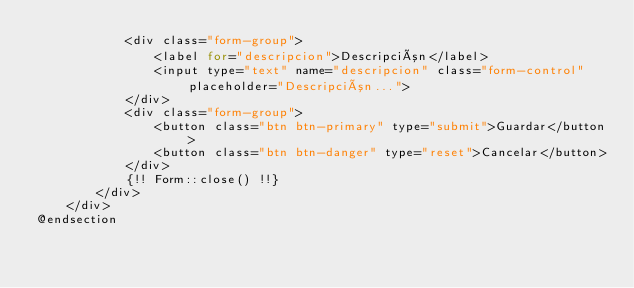Convert code to text. <code><loc_0><loc_0><loc_500><loc_500><_PHP_>            <div class="form-group">
                <label for="descripcion">Descripción</label>
                <input type="text" name="descripcion" class="form-control" placeholder="Descripción...">
            </div>
            <div class="form-group">
                <button class="btn btn-primary" type="submit">Guardar</button>
                <button class="btn btn-danger" type="reset">Cancelar</button>
            </div>
            {!! Form::close() !!}
        </div>
    </div>
@endsection
</code> 